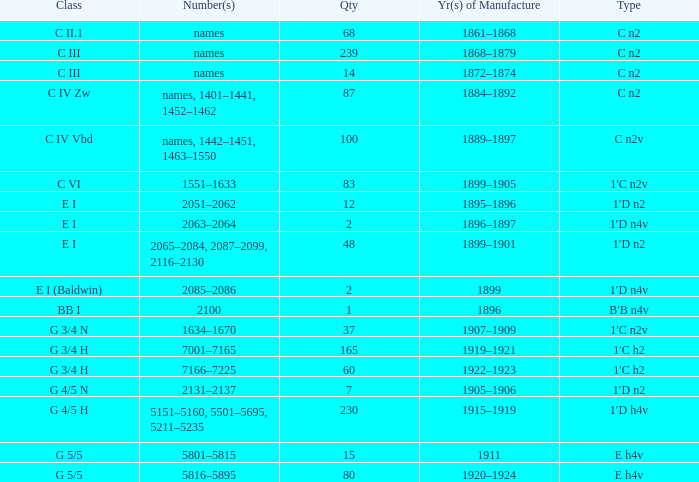Which Quantity has a Type of e h4v, and a Year(s) of Manufacture of 1920–1924? 80.0. 